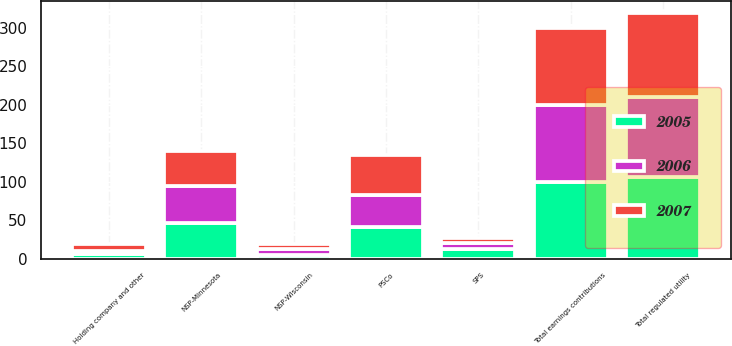<chart> <loc_0><loc_0><loc_500><loc_500><stacked_bar_chart><ecel><fcel>NSP-Minnesota<fcel>PSCo<fcel>SPS<fcel>NSP-Wisconsin<fcel>Total regulated utility<fcel>Holding company and other<fcel>Total earnings contributions<nl><fcel>2007<fcel>45.9<fcel>51<fcel>5.7<fcel>6.5<fcel>109.1<fcel>9.1<fcel>100<nl><fcel>2006<fcel>47.4<fcel>41.5<fcel>8.1<fcel>7.4<fcel>104.4<fcel>4.4<fcel>100<nl><fcel>2005<fcel>46.6<fcel>41.7<fcel>12.5<fcel>5<fcel>105.8<fcel>5.8<fcel>100<nl></chart> 